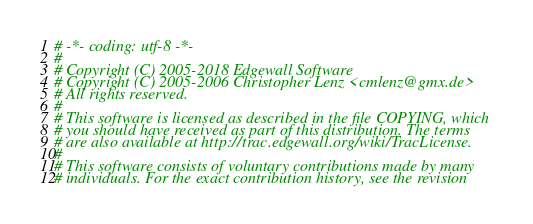<code> <loc_0><loc_0><loc_500><loc_500><_Python_># -*- coding: utf-8 -*-
#
# Copyright (C) 2005-2018 Edgewall Software
# Copyright (C) 2005-2006 Christopher Lenz <cmlenz@gmx.de>
# All rights reserved.
#
# This software is licensed as described in the file COPYING, which
# you should have received as part of this distribution. The terms
# are also available at http://trac.edgewall.org/wiki/TracLicense.
#
# This software consists of voluntary contributions made by many
# individuals. For the exact contribution history, see the revision</code> 